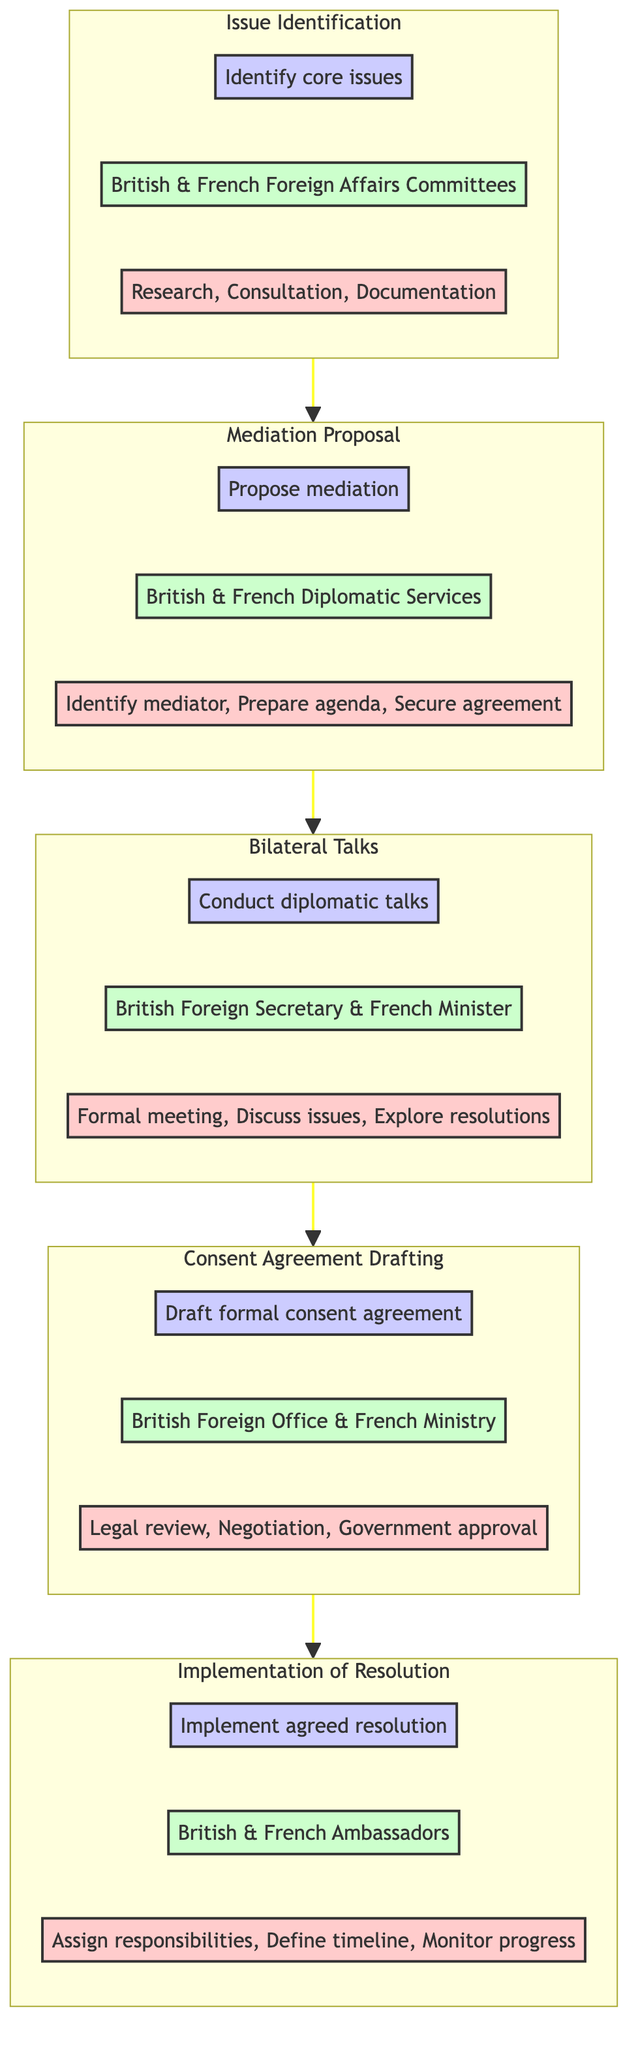What is the objective of the Issue Identification step? The diagram states that the objective of the Issue Identification step is to identify core issues. This is directly indicated under the respective subgraph.
Answer: Identify core issues Who are the stakeholders involved in the Mediation Proposal? The stakeholders listed in the Mediation Proposal subgraph are the British and French Diplomatic Services. This information is explicitly provided in the diagram.
Answer: British and French Diplomatic Services What action is included in the Consent Agreement Drafting? The Consent Agreement Drafting subgraph lists several actions, including legal review, negotiation, and government approval. These actions are clearly stated within the subgraph.
Answer: Legal review Which step comes before the Bilateral Talks? Referring to the flow direction of the diagram, the step that precedes Bilateral Talks is Mediation Proposal, as indicated by the flow arrows connecting the subgraphs.
Answer: Mediation Proposal What is the last step of the dispute resolution process? According to the flowchart, the last step of the process is Implementation of Resolution. The flow clearly shows that this subgraph is the final destination in the sequence of steps.
Answer: Implementation of Resolution How many actions are listed under the Implementation of Resolution? The Implementation of Resolution subgraph includes three actions, which are assigning responsibilities, defining timeline, and monitoring progress, as indicated within that section.
Answer: Three What is the relationship between Issue Identification and Mediation Proposal? The relationship is that Issue Identification flows into Mediation Proposal, meaning that upon completion of identifying issues, the process progresses to proposing mediation as the next step in resolving the dispute.
Answer: Flows into What is the main focus of the Bilateral Talks step? The main focus of the Bilateral Talks step is to conduct diplomatic talks to resolve the dispute, as described in the objective provided within the subgraph.
Answer: Conduct diplomatic talks What step follows the Consent Agreement Drafting in the flowchart? Following the Consent Agreement Drafting in the flowchart is the Implementation of Resolution, indicated by the flow direction leading from the Consent Agreement Drafting to this subsequent step.
Answer: Implementation of Resolution 